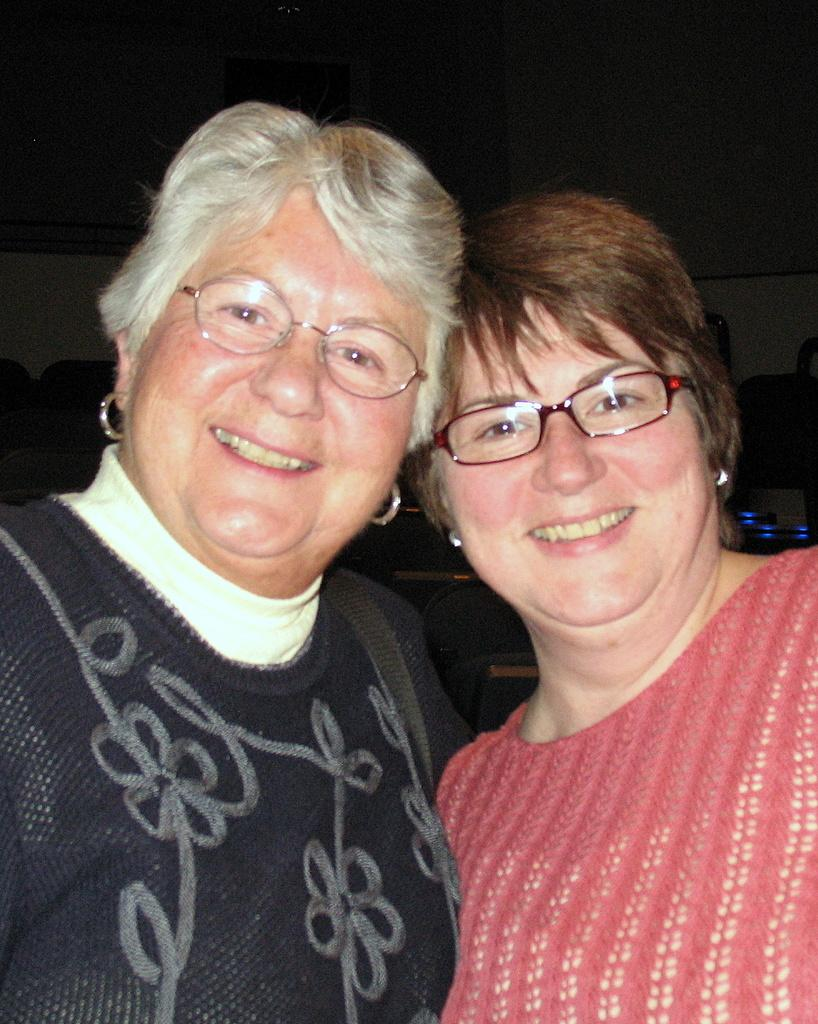How many people are in the image? There are two women in the image. What expressions do the women have? Both women are smiling. What accessory are the women wearing? The women are wearing glasses. What type of flowers can be seen on the breakfast table in the image? There is no mention of flowers or a breakfast table in the image; it only features two women wearing glasses and smiling. 